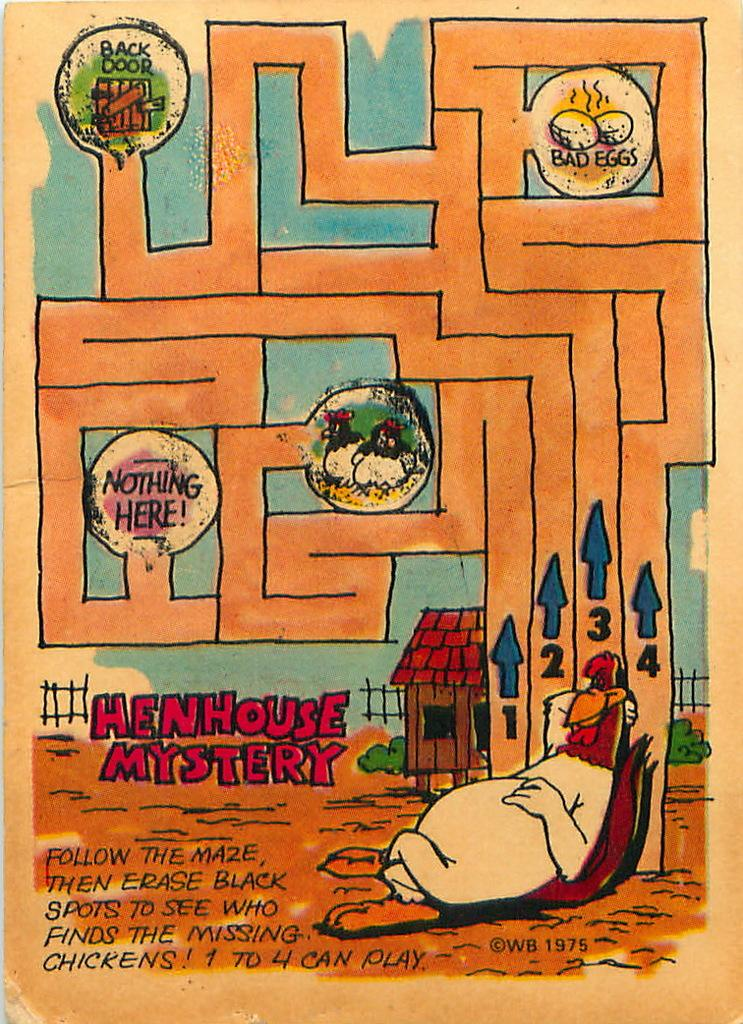<image>
Create a compact narrative representing the image presented. A childs maze that is titled Henhouse mystery 